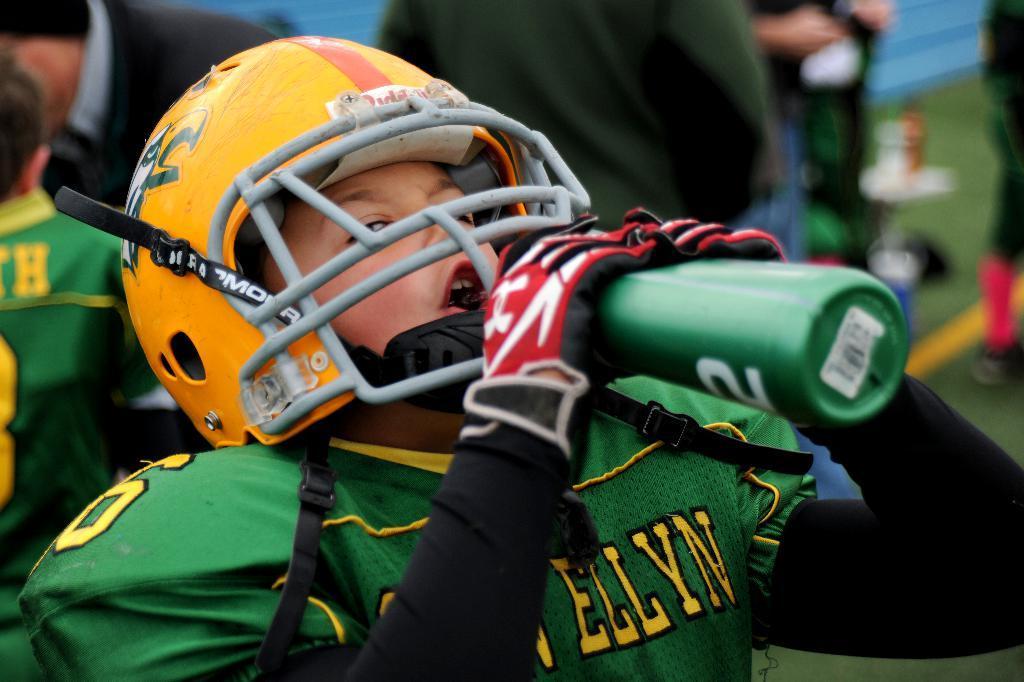How would you summarize this image in a sentence or two? This image consists of many people. In the front, a person is drinking water. He is wearing a green color sports dress. And we can see the grass on the ground. 